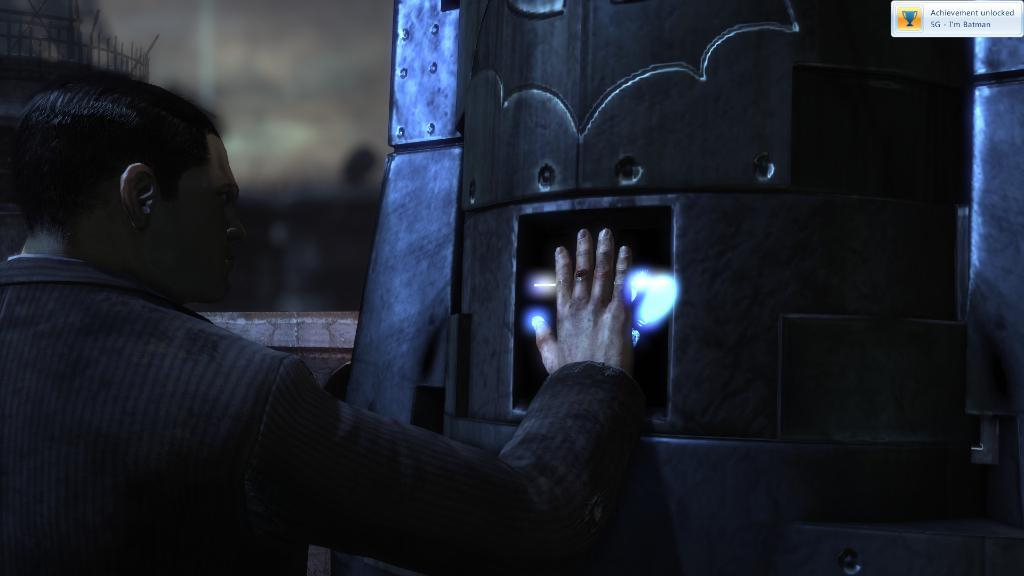What is the main subject of the image? The main subject of the image is a man. What is the man doing in the image? The man is standing in the image. Is the man interacting with any objects in the image? Yes, the man is touching an object in the image. What type of truck can be seen driving through the man's wound in the image? There is no truck or wound present in the image, and therefore no such interaction can be observed. 